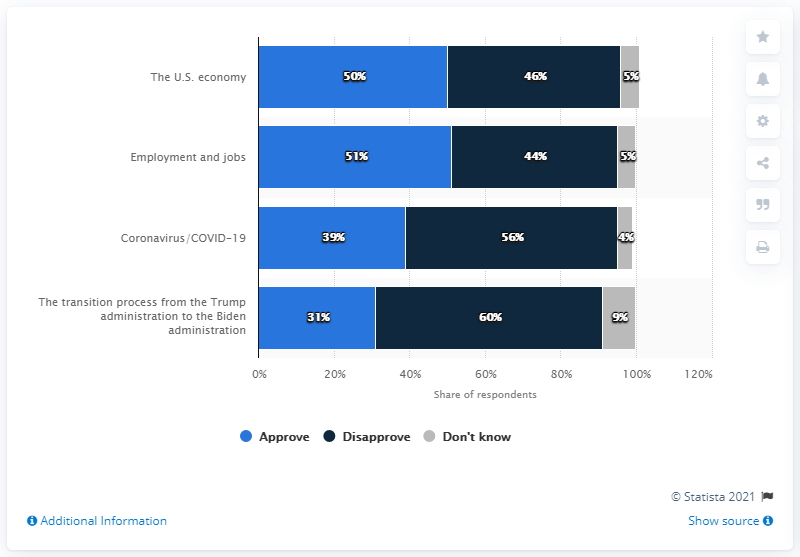Indicate a few pertinent items in this graphic. The difference between the highest and lowest values of the light blue bar is 20. The blue bar with the least percentage value is 31%. 